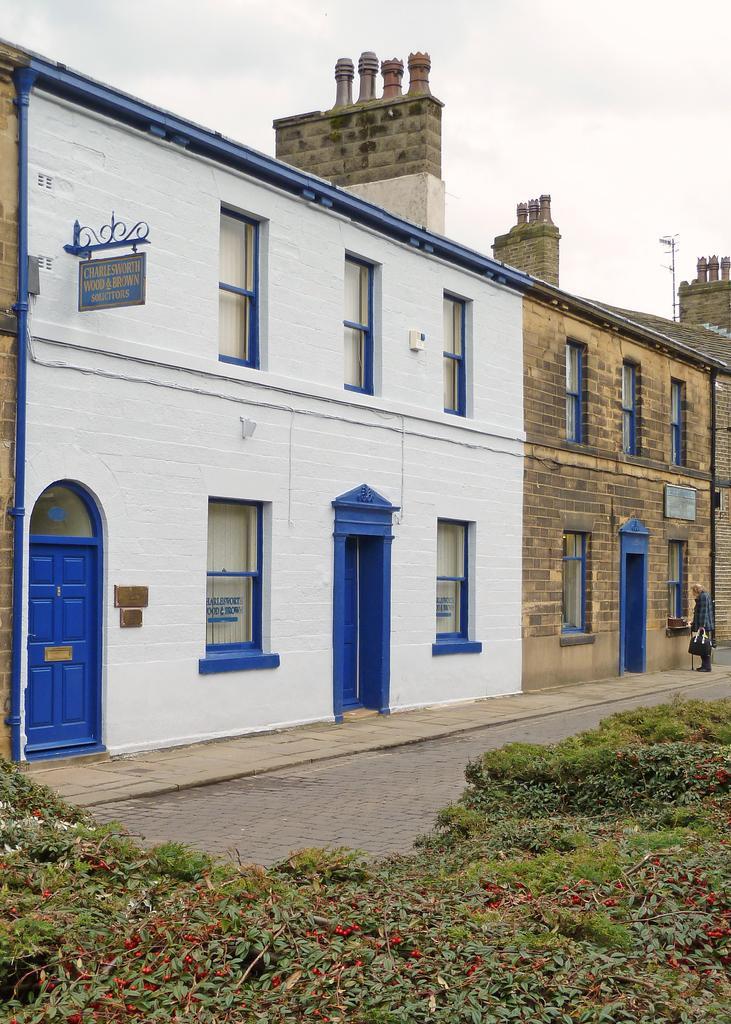In one or two sentences, can you explain what this image depicts? This image is taken outdoors. At the top of the image there is a sky with clouds. At the bottom of the image there are a few plants and there is a floor. On the right side of the image a man is standing on the sidewalk. In the middle of the image there is a building with walls, windows and doors. There is a board with a text on it. 